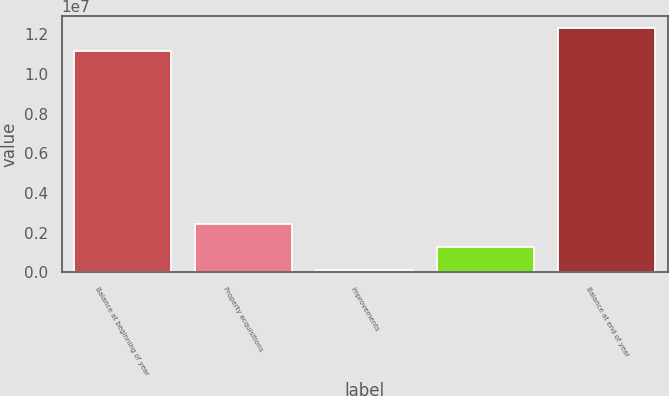Convert chart. <chart><loc_0><loc_0><loc_500><loc_500><bar_chart><fcel>Balance at beginning of year<fcel>Property acquisitions<fcel>Improvements<fcel>Unnamed: 3<fcel>Balance at end of year<nl><fcel>1.11472e+07<fcel>2.44972e+06<fcel>146410<fcel>1.29806e+06<fcel>1.22988e+07<nl></chart> 